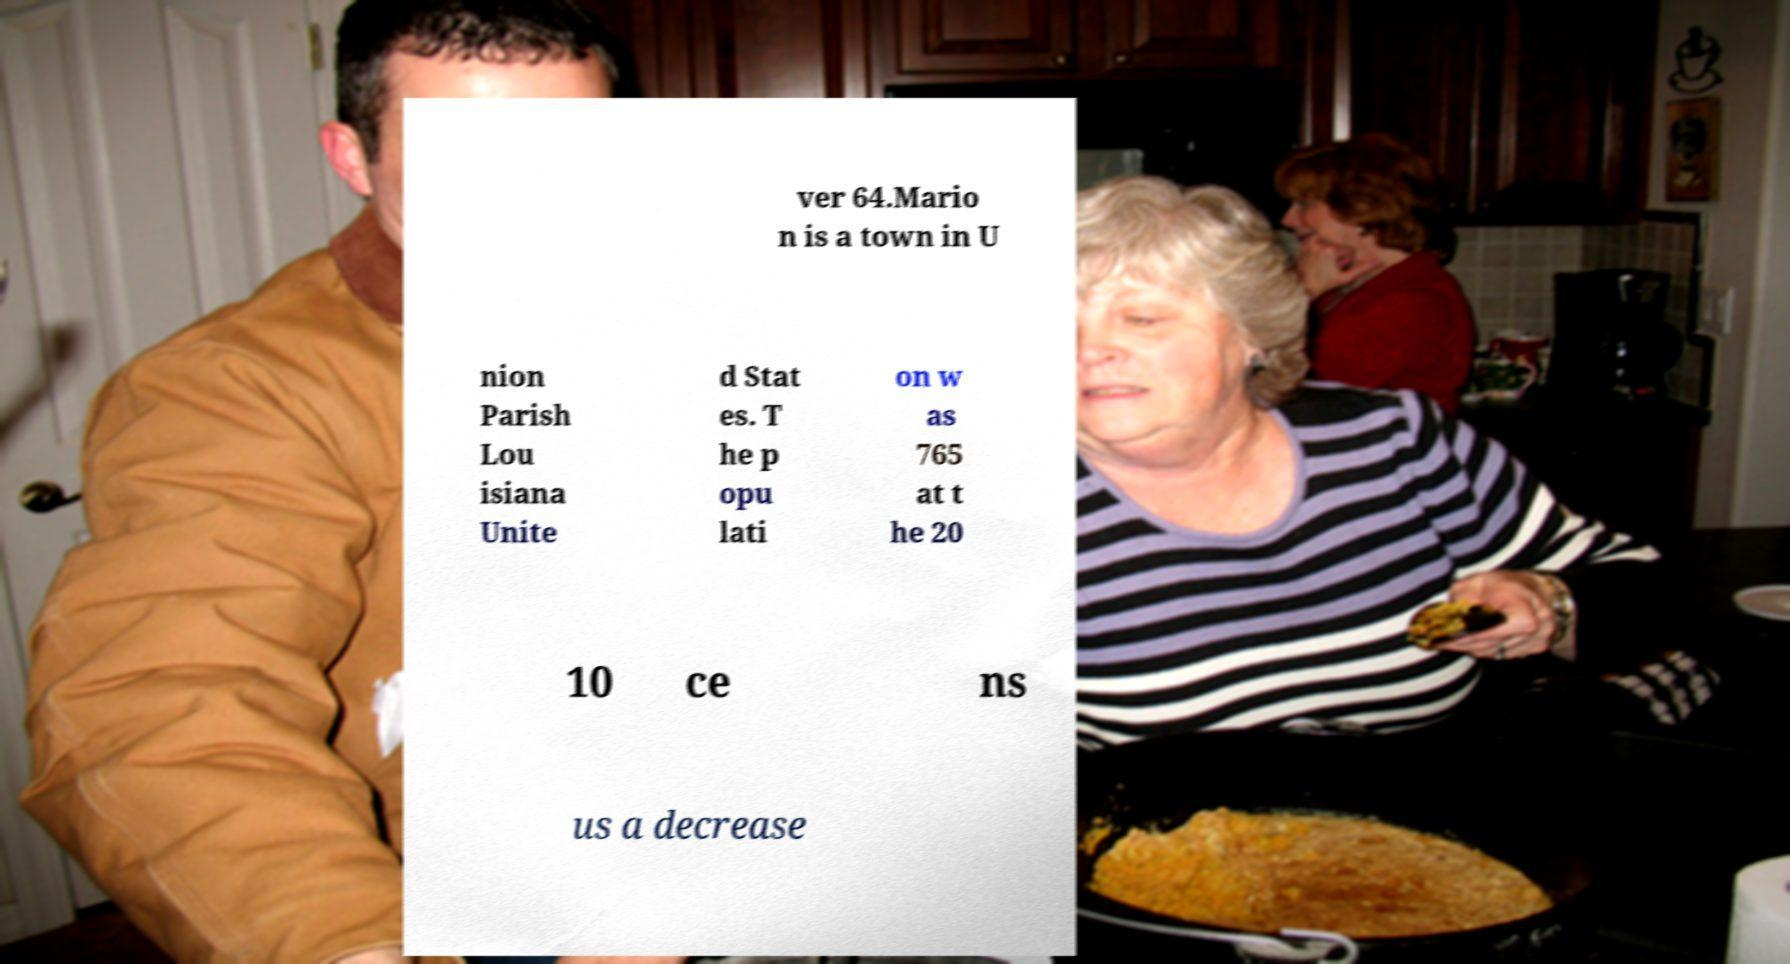What messages or text are displayed in this image? I need them in a readable, typed format. ver 64.Mario n is a town in U nion Parish Lou isiana Unite d Stat es. T he p opu lati on w as 765 at t he 20 10 ce ns us a decrease 